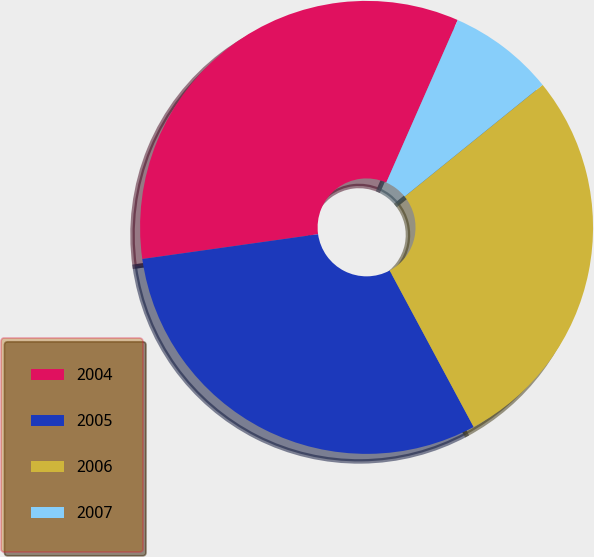<chart> <loc_0><loc_0><loc_500><loc_500><pie_chart><fcel>2004<fcel>2005<fcel>2006<fcel>2007<nl><fcel>33.82%<fcel>30.61%<fcel>27.99%<fcel>7.58%<nl></chart> 